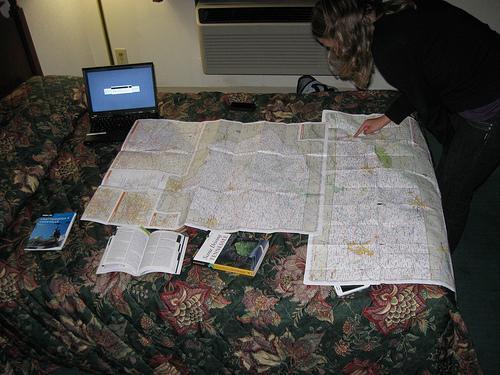How many maps are spread out over the bed?
Give a very brief answer. 2. How many books are on the bed?
Give a very brief answer. 3. How many people are in this photo?
Give a very brief answer. 1. 